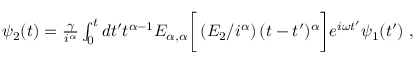Convert formula to latex. <formula><loc_0><loc_0><loc_500><loc_500>\begin{array} { r } { \psi _ { 2 } ( t ) = \frac { \gamma } { i ^ { \alpha } } \int _ { 0 } ^ { t } d t ^ { \prime } t ^ { \alpha - 1 } E _ { \alpha , \alpha } \left [ \left ( E _ { 2 } / i ^ { \alpha } \right ) ( t - t ^ { \prime } ) ^ { \alpha } \right ] e ^ { i \omega t ^ { \prime } } \psi _ { 1 } ( t ^ { \prime } ) \, , } \end{array}</formula> 